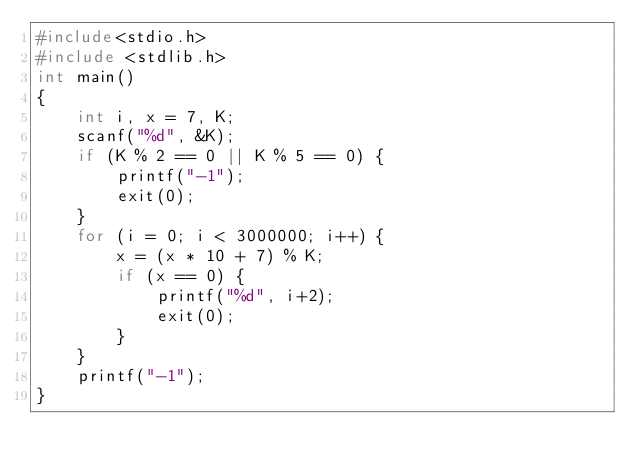<code> <loc_0><loc_0><loc_500><loc_500><_C_>#include<stdio.h>
#include <stdlib.h>
int main()
{
	int i, x = 7, K;
	scanf("%d", &K);
	if (K % 2 == 0 || K % 5 == 0) {
		printf("-1");
		exit(0);
	}
	for (i = 0; i < 3000000; i++) {
		x = (x * 10 + 7) % K;
		if (x == 0) {
			printf("%d", i+2);
			exit(0);
		}
	}
	printf("-1");
}
</code> 